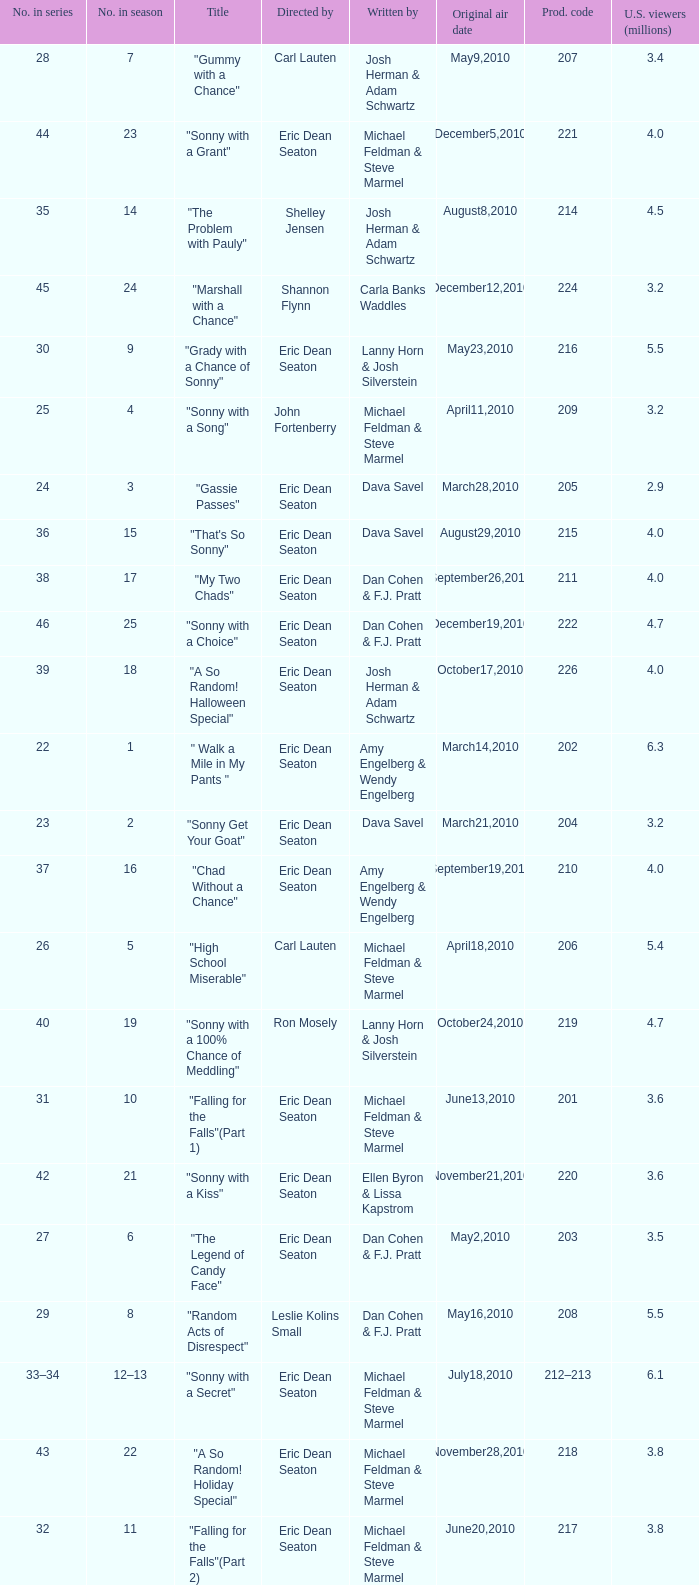How man episodes in the season were titled "that's so sonny"? 1.0. 